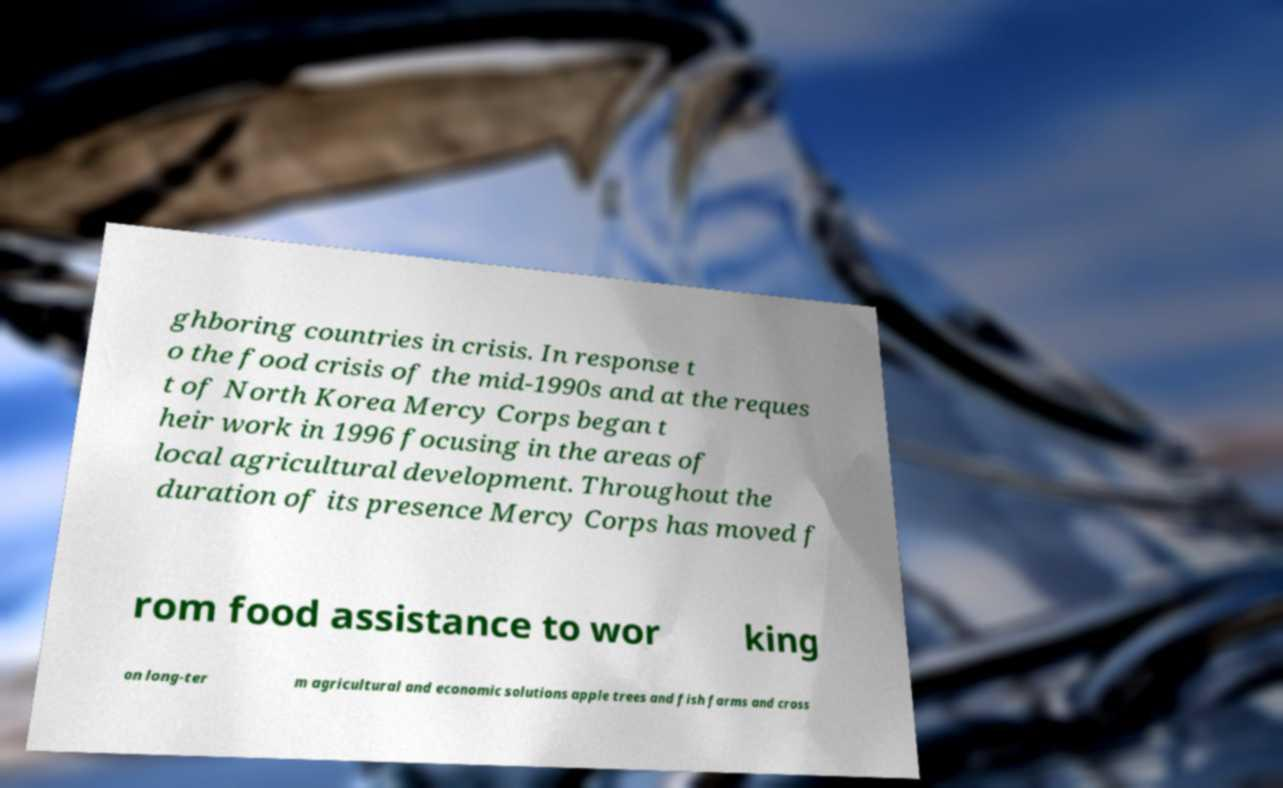Can you read and provide the text displayed in the image?This photo seems to have some interesting text. Can you extract and type it out for me? ghboring countries in crisis. In response t o the food crisis of the mid-1990s and at the reques t of North Korea Mercy Corps began t heir work in 1996 focusing in the areas of local agricultural development. Throughout the duration of its presence Mercy Corps has moved f rom food assistance to wor king on long-ter m agricultural and economic solutions apple trees and fish farms and cross 